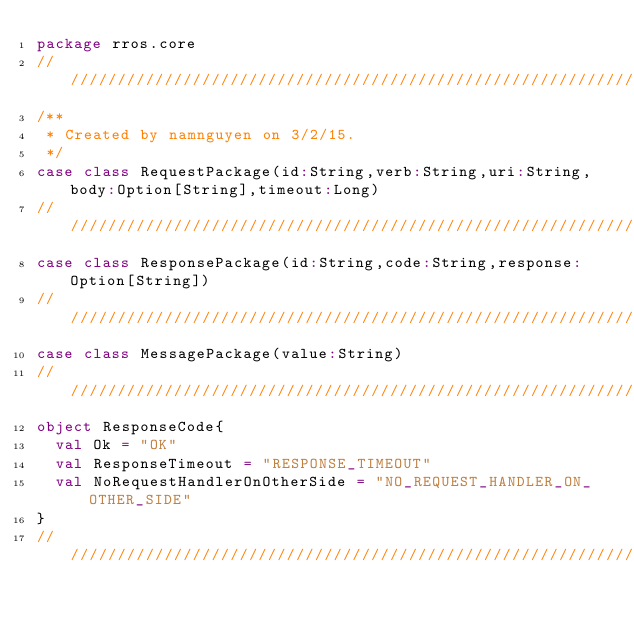<code> <loc_0><loc_0><loc_500><loc_500><_Scala_>package rros.core
////////////////////////////////////////////////////////////////////////////////
/**
 * Created by namnguyen on 3/2/15.
 */
case class RequestPackage(id:String,verb:String,uri:String,body:Option[String],timeout:Long)
////////////////////////////////////////////////////////////////////////////////
case class ResponsePackage(id:String,code:String,response:Option[String])
////////////////////////////////////////////////////////////////////////////////
case class MessagePackage(value:String)
////////////////////////////////////////////////////////////////////////////////
object ResponseCode{
  val Ok = "OK"
  val ResponseTimeout = "RESPONSE_TIMEOUT"
  val NoRequestHandlerOnOtherSide = "NO_REQUEST_HANDLER_ON_OTHER_SIDE"
}
////////////////////////////////////////////////////////////////////////////////</code> 